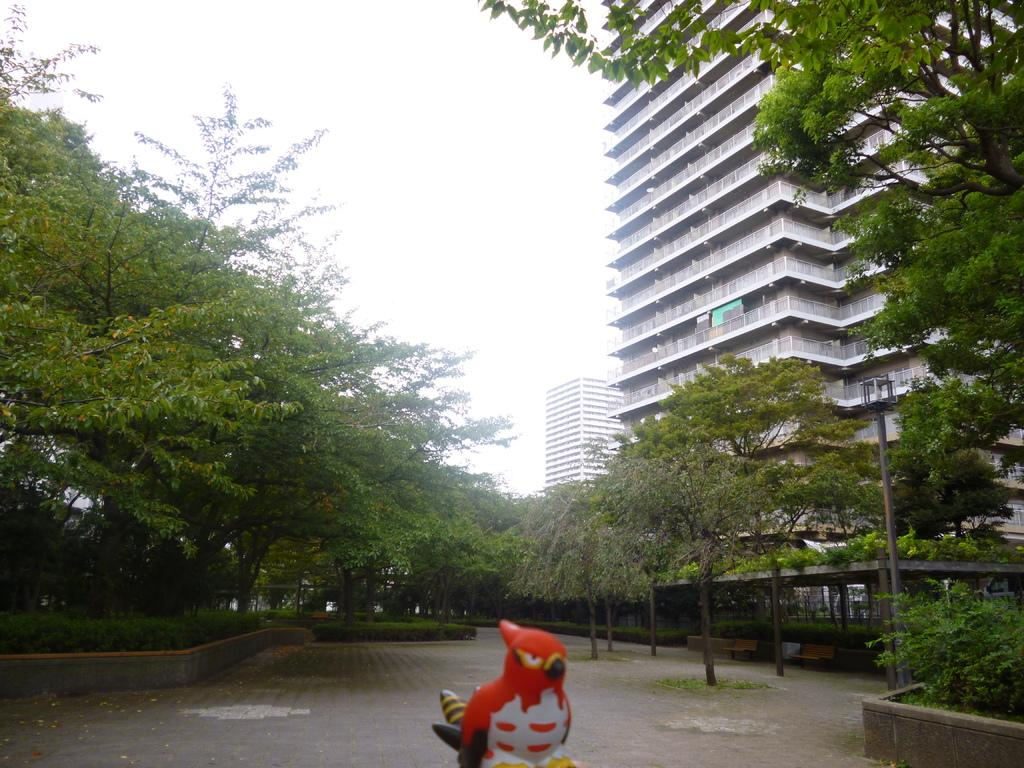What type of natural elements can be seen in the image? There are trees and plants in the image. What man-made structures are present in the image? There are poles and a fence in the image. What is on the ground in the image? There are objects on the ground in the image. What can be seen in the background of the image? There are buildings and the sky visible in the background of the image. Can you tell me how many police officers are visible in the image? There are no police officers present in the image. What type of blade is being used to trim the plants in the image? There is no blade visible in the image, and the plants do not appear to be trimmed. 